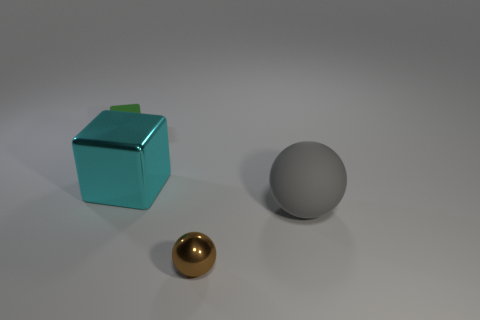What number of objects are both on the left side of the gray thing and to the right of the tiny green cube?
Provide a short and direct response. 2. The sphere that is on the left side of the matte object that is in front of the large cyan thing is what color?
Keep it short and to the point. Brown. Is the number of tiny metal objects that are behind the matte ball the same as the number of big shiny cylinders?
Your response must be concise. Yes. How many cyan metallic objects are behind the rubber thing that is to the left of the cyan metallic block to the left of the rubber sphere?
Give a very brief answer. 0. There is a ball in front of the large gray rubber thing; what is its color?
Provide a succinct answer. Brown. There is a object that is behind the brown thing and right of the large cyan block; what is its material?
Keep it short and to the point. Rubber. There is a metallic object that is in front of the gray rubber object; what number of small brown spheres are right of it?
Provide a succinct answer. 0. The green thing has what shape?
Make the answer very short. Cube. What shape is the object that is the same material as the cyan cube?
Provide a succinct answer. Sphere. Do the small object that is in front of the tiny rubber thing and the big cyan metallic object have the same shape?
Your response must be concise. No. 